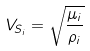<formula> <loc_0><loc_0><loc_500><loc_500>V _ { S _ { i } } = \sqrt { \frac { \mu _ { i } } { \rho _ { i } } }</formula> 